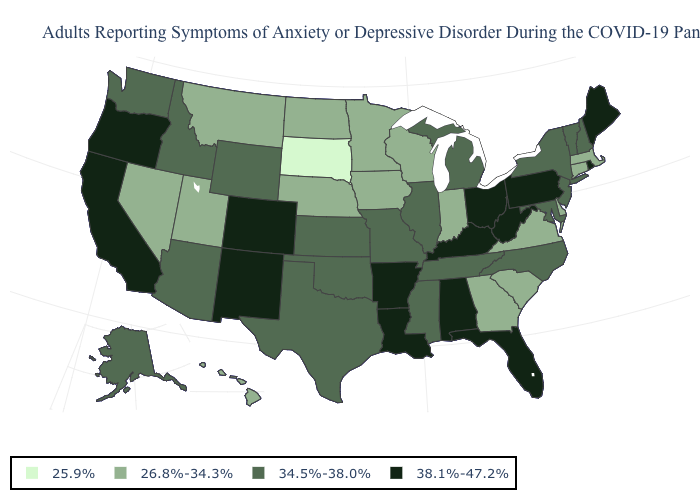What is the value of Connecticut?
Keep it brief. 26.8%-34.3%. What is the value of Hawaii?
Short answer required. 26.8%-34.3%. Does South Dakota have the lowest value in the MidWest?
Write a very short answer. Yes. Which states have the lowest value in the South?
Concise answer only. Delaware, Georgia, South Carolina, Virginia. What is the lowest value in the Northeast?
Answer briefly. 26.8%-34.3%. Name the states that have a value in the range 38.1%-47.2%?
Quick response, please. Alabama, Arkansas, California, Colorado, Florida, Kentucky, Louisiana, Maine, New Mexico, Ohio, Oregon, Pennsylvania, Rhode Island, West Virginia. Name the states that have a value in the range 34.5%-38.0%?
Keep it brief. Alaska, Arizona, Idaho, Illinois, Kansas, Maryland, Michigan, Mississippi, Missouri, New Hampshire, New Jersey, New York, North Carolina, Oklahoma, Tennessee, Texas, Vermont, Washington, Wyoming. Does South Dakota have the lowest value in the MidWest?
Give a very brief answer. Yes. Does Indiana have a lower value than Tennessee?
Write a very short answer. Yes. Name the states that have a value in the range 38.1%-47.2%?
Concise answer only. Alabama, Arkansas, California, Colorado, Florida, Kentucky, Louisiana, Maine, New Mexico, Ohio, Oregon, Pennsylvania, Rhode Island, West Virginia. What is the lowest value in the USA?
Keep it brief. 25.9%. Does Nebraska have the lowest value in the USA?
Quick response, please. No. What is the value of Michigan?
Keep it brief. 34.5%-38.0%. Which states have the highest value in the USA?
Answer briefly. Alabama, Arkansas, California, Colorado, Florida, Kentucky, Louisiana, Maine, New Mexico, Ohio, Oregon, Pennsylvania, Rhode Island, West Virginia. What is the value of Oregon?
Short answer required. 38.1%-47.2%. 